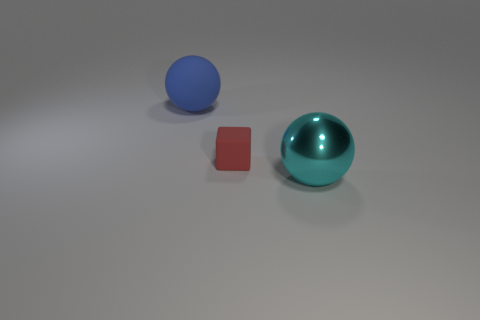How many other objects are there of the same material as the tiny cube?
Offer a terse response. 1. Are the big sphere that is behind the big cyan shiny sphere and the large sphere in front of the red matte thing made of the same material?
Your answer should be compact. No. Are there any other things that have the same shape as the cyan shiny object?
Your answer should be compact. Yes. Is the material of the big blue ball the same as the ball that is to the right of the blue object?
Ensure brevity in your answer.  No. What color is the big sphere right of the ball behind the large thing that is to the right of the big blue matte ball?
Your answer should be very brief. Cyan. Is there any other thing that has the same size as the red cube?
Your answer should be compact. No. There is a sphere that is on the left side of the big metal ball; does it have the same size as the thing that is in front of the red matte cube?
Keep it short and to the point. Yes. There is a matte thing that is right of the blue ball; how big is it?
Keep it short and to the point. Small. There is a rubber thing that is the same size as the cyan ball; what color is it?
Your response must be concise. Blue. Is the size of the blue rubber object the same as the cyan metallic ball?
Your answer should be very brief. Yes. 